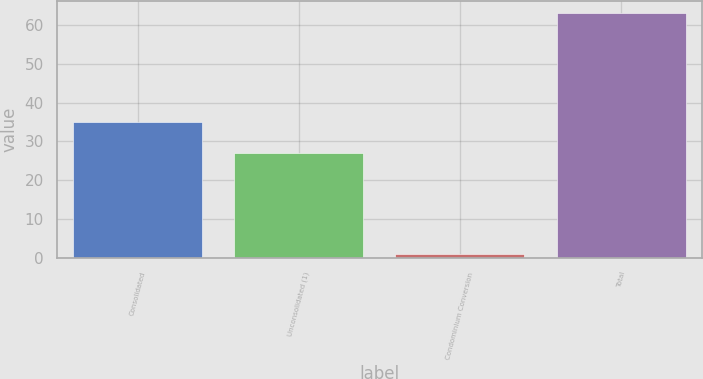Convert chart to OTSL. <chart><loc_0><loc_0><loc_500><loc_500><bar_chart><fcel>Consolidated<fcel>Unconsolidated (1)<fcel>Condominium Conversion<fcel>Total<nl><fcel>35<fcel>27<fcel>1<fcel>63<nl></chart> 